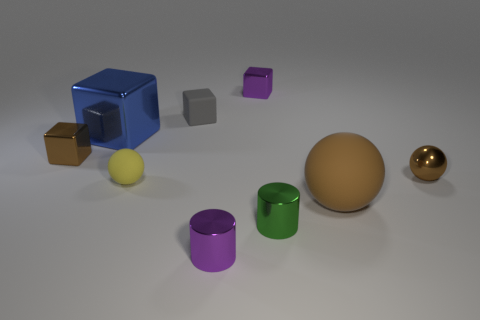There is a small metallic ball; does it have the same color as the large object that is behind the large matte thing?
Provide a short and direct response. No. Is there a tiny green block made of the same material as the small green thing?
Offer a very short reply. No. What number of brown metal spheres are there?
Give a very brief answer. 1. There is a tiny cube that is on the right side of the small purple shiny thing in front of the tiny gray block; what is its material?
Provide a short and direct response. Metal. What is the color of the small block that is the same material as the small yellow thing?
Your answer should be compact. Gray. There is a tiny shiny object that is the same color as the small metallic ball; what is its shape?
Ensure brevity in your answer.  Cube. There is a brown metal thing that is right of the small brown block; is it the same size as the purple object in front of the tiny green shiny object?
Offer a terse response. Yes. What number of blocks are either yellow objects or brown metallic objects?
Make the answer very short. 1. Is the material of the large thing left of the green metallic thing the same as the yellow sphere?
Provide a succinct answer. No. What number of other objects are there of the same size as the purple metal cylinder?
Provide a short and direct response. 6. 